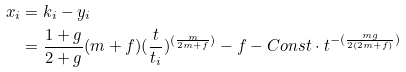Convert formula to latex. <formula><loc_0><loc_0><loc_500><loc_500>x _ { i } & = k _ { i } - y _ { i } \\ & = \frac { 1 + g } { 2 + g } ( m + f ) ( \frac { t } { t _ { i } } ) ^ { ( \frac { m } { 2 m + f } ) } - f - C o n s t \cdot t ^ { - ( \frac { m g } { 2 ( 2 m + f ) } ) }</formula> 